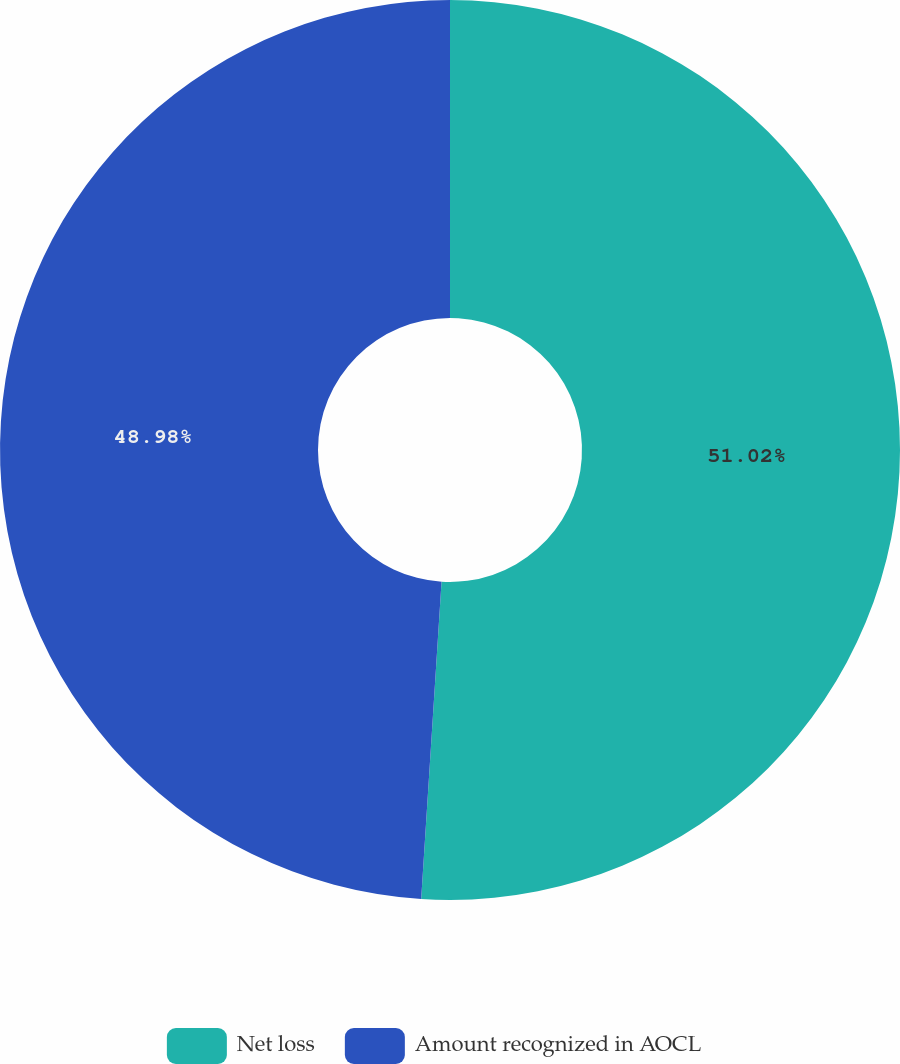Convert chart. <chart><loc_0><loc_0><loc_500><loc_500><pie_chart><fcel>Net loss<fcel>Amount recognized in AOCL<nl><fcel>51.02%<fcel>48.98%<nl></chart> 